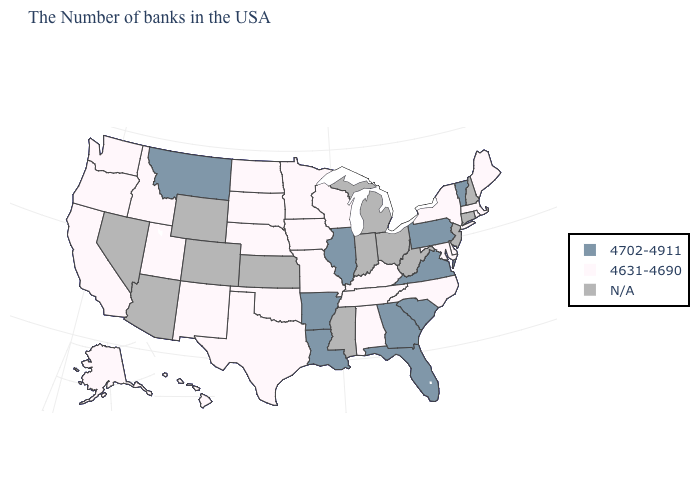What is the lowest value in the MidWest?
Keep it brief. 4631-4690. How many symbols are there in the legend?
Quick response, please. 3. Which states have the lowest value in the West?
Write a very short answer. New Mexico, Utah, Idaho, California, Washington, Oregon, Alaska, Hawaii. Name the states that have a value in the range N/A?
Answer briefly. New Hampshire, Connecticut, New Jersey, West Virginia, Ohio, Michigan, Indiana, Mississippi, Kansas, Wyoming, Colorado, Arizona, Nevada. Does Oregon have the lowest value in the USA?
Quick response, please. Yes. Among the states that border Delaware , does Pennsylvania have the lowest value?
Be succinct. No. Is the legend a continuous bar?
Quick response, please. No. How many symbols are there in the legend?
Be succinct. 3. What is the value of New Hampshire?
Quick response, please. N/A. Which states have the lowest value in the Northeast?
Short answer required. Maine, Massachusetts, Rhode Island, New York. Among the states that border South Carolina , does North Carolina have the highest value?
Concise answer only. No. What is the lowest value in states that border Ohio?
Concise answer only. 4631-4690. 